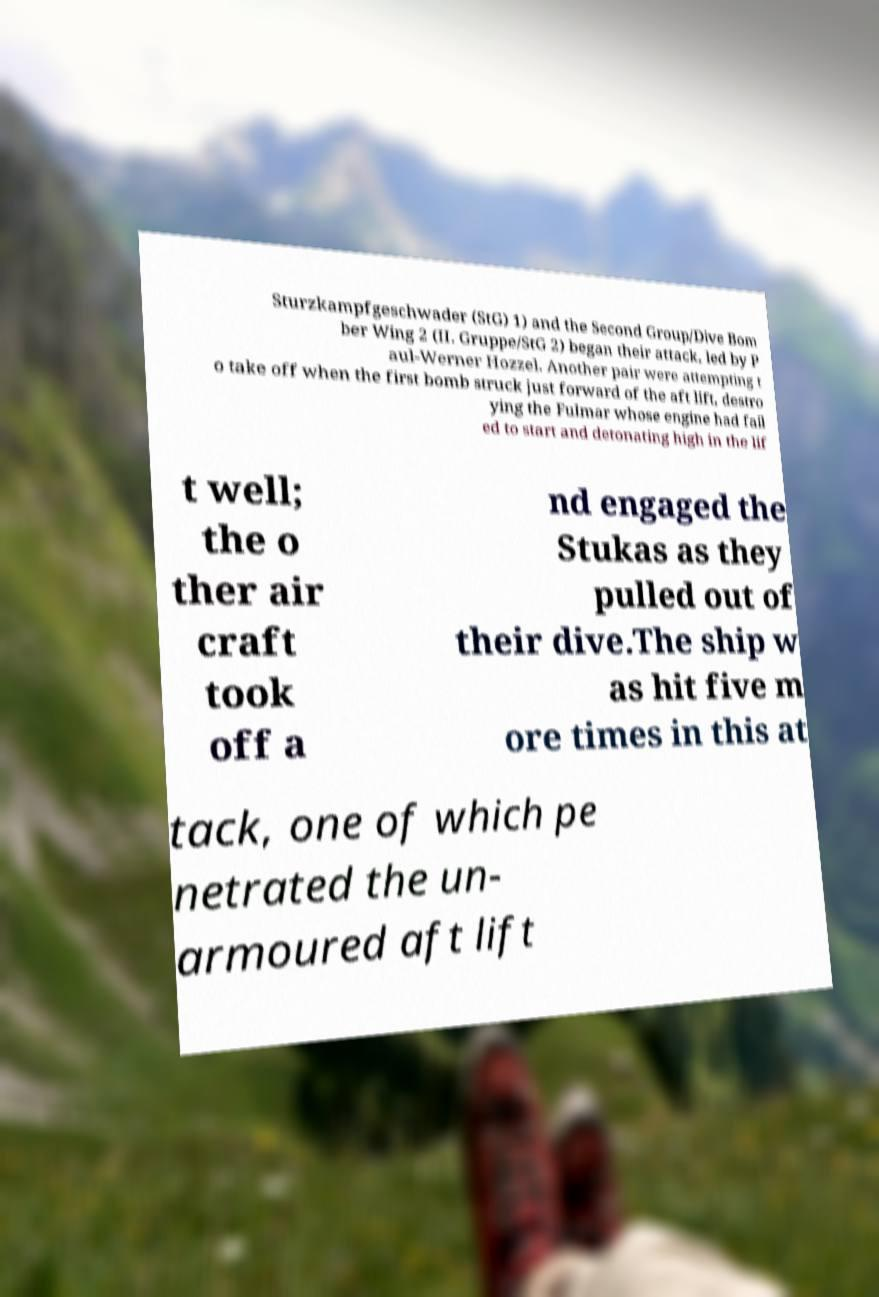Can you accurately transcribe the text from the provided image for me? Sturzkampfgeschwader (StG) 1) and the Second Group/Dive Bom ber Wing 2 (II. Gruppe/StG 2) began their attack, led by P aul-Werner Hozzel. Another pair were attempting t o take off when the first bomb struck just forward of the aft lift, destro ying the Fulmar whose engine had fail ed to start and detonating high in the lif t well; the o ther air craft took off a nd engaged the Stukas as they pulled out of their dive.The ship w as hit five m ore times in this at tack, one of which pe netrated the un- armoured aft lift 